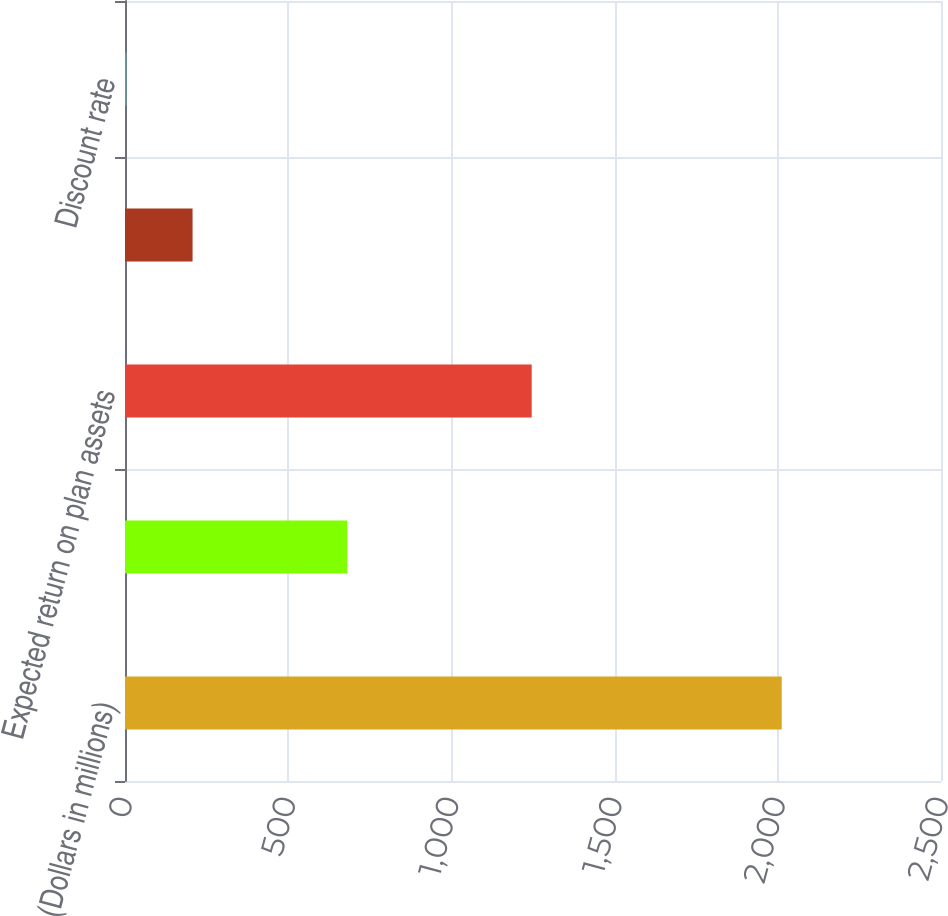<chart> <loc_0><loc_0><loc_500><loc_500><bar_chart><fcel>(Dollars in millions)<fcel>Interest cost<fcel>Expected return on plan assets<fcel>Net periodic benefit cost<fcel>Discount rate<nl><fcel>2012<fcel>681<fcel>1246<fcel>207<fcel>4.95<nl></chart> 